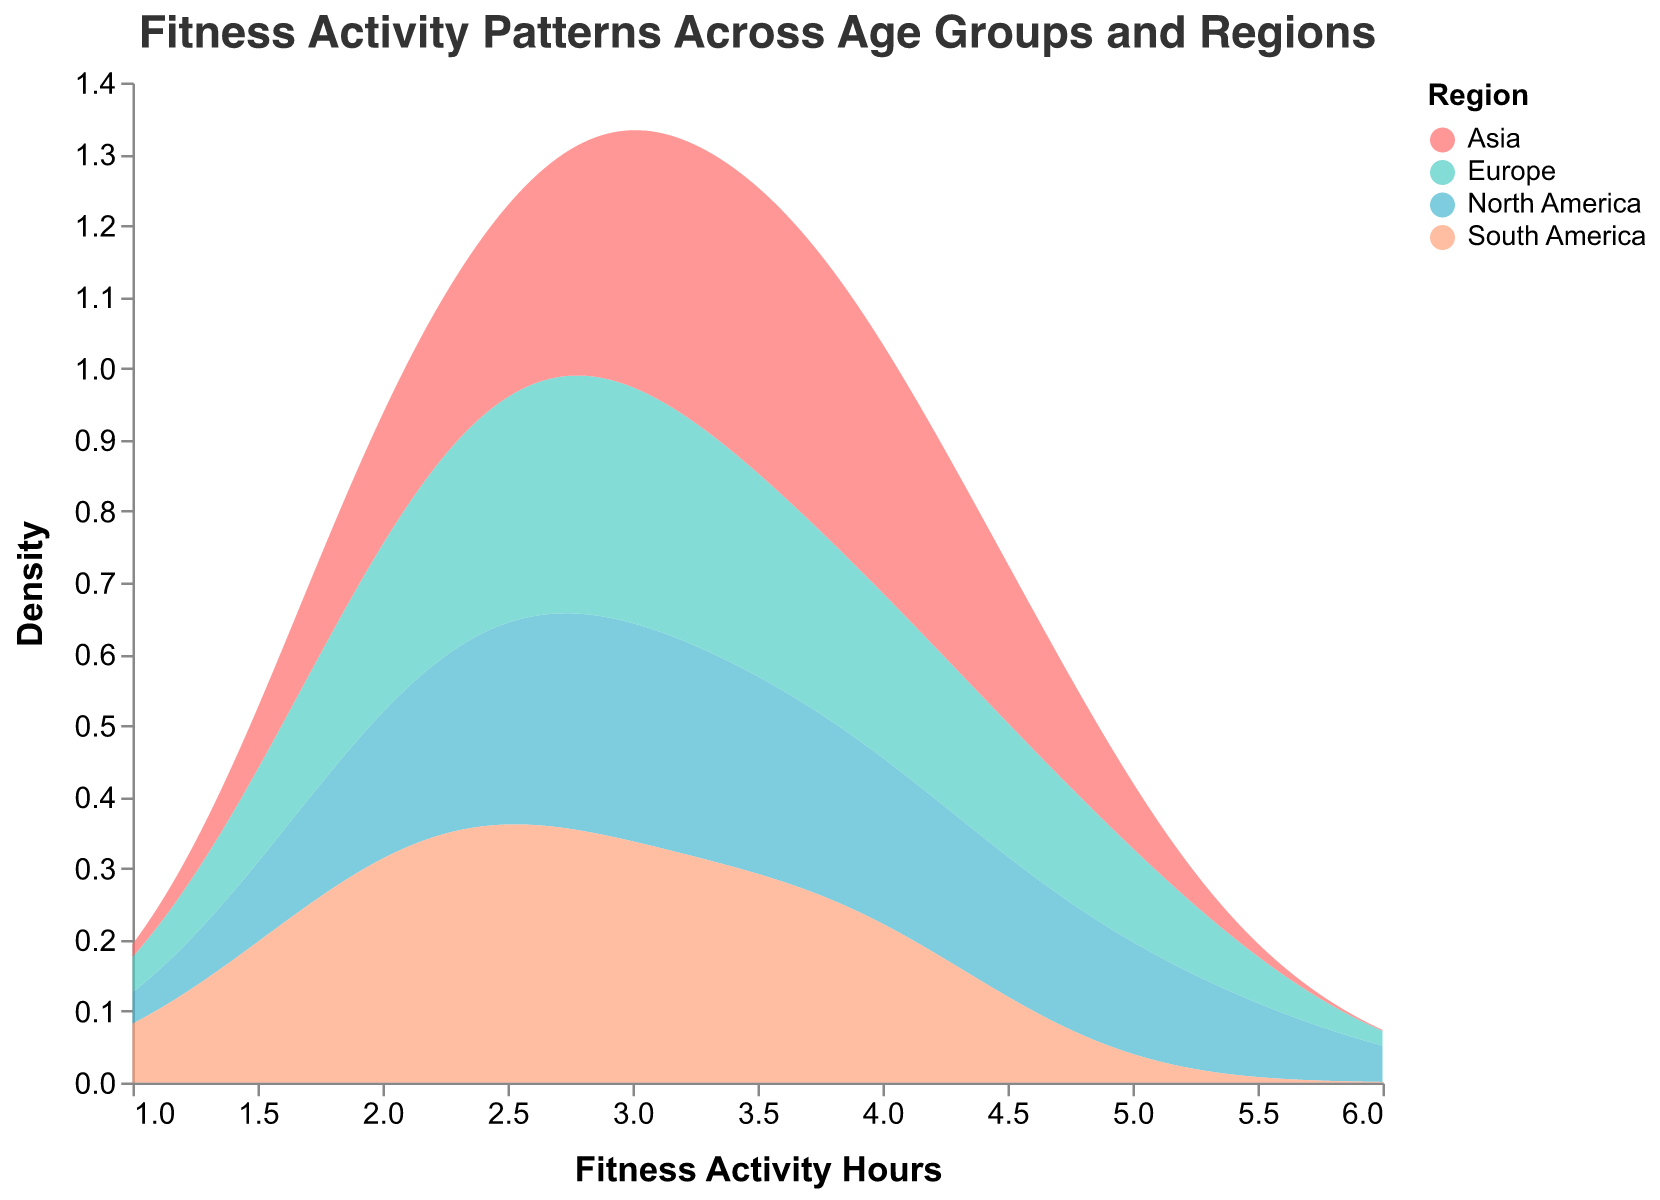What is the title of the figure? The title is typically placed at the top of the figure and provides a summary of what the plot represents.
Answer: Fitness Activity Patterns Across Age Groups and Regions How many regions are represented by different colors in the plot? By examining the color legend, you can count the distinct colors, each representing a unique region.
Answer: 4 What is the typical range of fitness activity hours shown on the x-axis? The x-axis range is determined by the minimum and maximum values indicated, observable from the start and end ticks on the axis.
Answer: 1 to 6 Which region shows the highest density of fitness activity hours? Identifying the peak of the density curves for each region allows us to see which one reaches the highest point on the y-axis.
Answer: North America How do the fitness activity hours of the 25-34 age group compare across regions? To answer this, you would compare where the density peaks are located for each color representing the regions for the 25-34 age group on the x-axis.
Answer: North America and Europe have higher fitness activity hours than Asia and South America Are there any regions with similar patterns of fitness activity? Look for regions whose density curves have similar shapes and peaks.
Answer: Europe and Asia What is the density value for North America at 3 fitness activity hours? Find North America's density curve and check its y-axis value at the x-axis point of 3 fitness activity hours.
Answer: Approximately 0.12 Which age group shows the lowest fitness activity hours in South America? Examine the sections of the plot corresponding to South America; look for the peak in density on the lower end of the x-axis.
Answer: 65+ How does the density peak for the fitness activity hours at 2.5 hours compare between Europe and Asia? Check the y-axis values where the fitness activity hours are 2.5 for both Europe's and Asia's density curves and compare their heights.
Answer: Asia is slightly higher than Europe What is the general trend of fitness activity hours as age increases across all regions? Observe the peaks of the density curves for each age group and note any shifting trend from higher to lower fitness activity hours as the age increases.
Answer: Decreases 